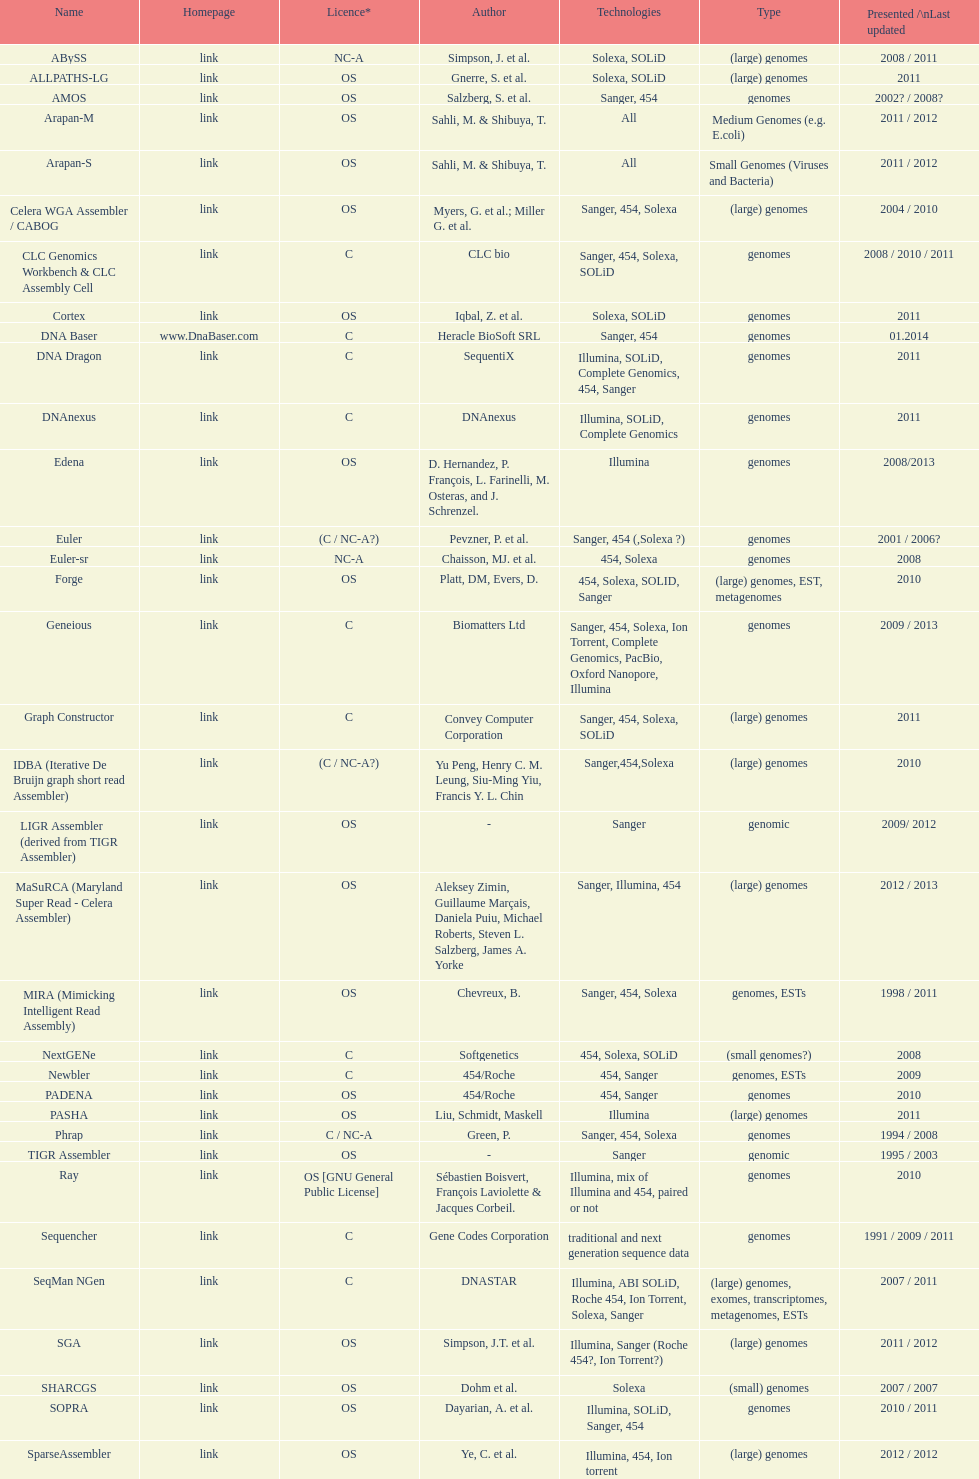Which license is listed more, os or c? OS. 